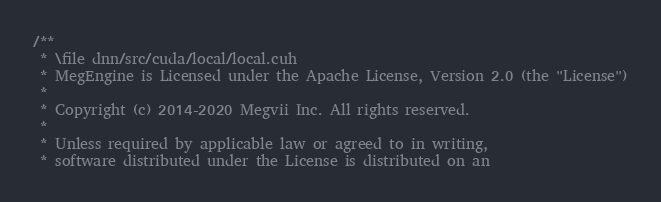<code> <loc_0><loc_0><loc_500><loc_500><_Cuda_>/**
 * \file dnn/src/cuda/local/local.cuh
 * MegEngine is Licensed under the Apache License, Version 2.0 (the "License")
 *
 * Copyright (c) 2014-2020 Megvii Inc. All rights reserved.
 *
 * Unless required by applicable law or agreed to in writing,
 * software distributed under the License is distributed on an</code> 